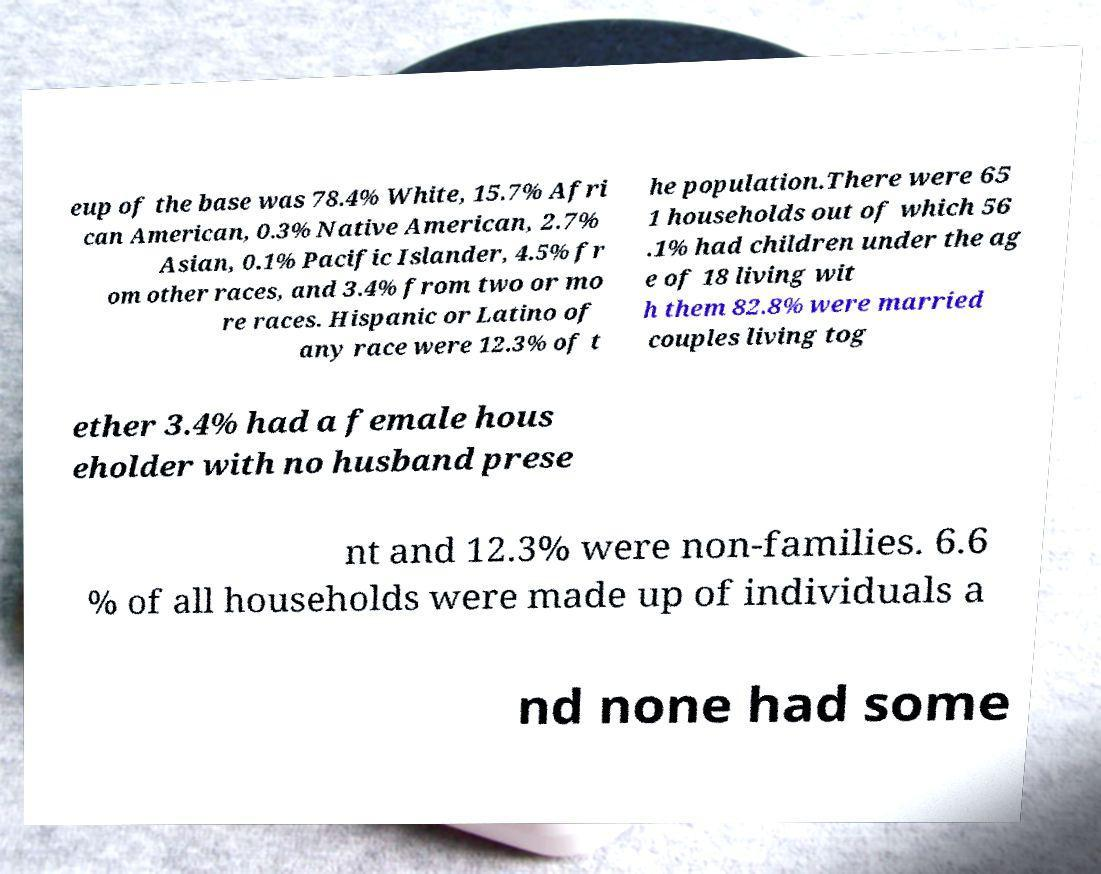Could you extract and type out the text from this image? eup of the base was 78.4% White, 15.7% Afri can American, 0.3% Native American, 2.7% Asian, 0.1% Pacific Islander, 4.5% fr om other races, and 3.4% from two or mo re races. Hispanic or Latino of any race were 12.3% of t he population.There were 65 1 households out of which 56 .1% had children under the ag e of 18 living wit h them 82.8% were married couples living tog ether 3.4% had a female hous eholder with no husband prese nt and 12.3% were non-families. 6.6 % of all households were made up of individuals a nd none had some 